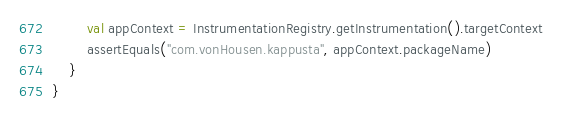Convert code to text. <code><loc_0><loc_0><loc_500><loc_500><_Kotlin_>        val appContext = InstrumentationRegistry.getInstrumentation().targetContext
        assertEquals("com.vonHousen.kappusta", appContext.packageName)
    }
}
</code> 